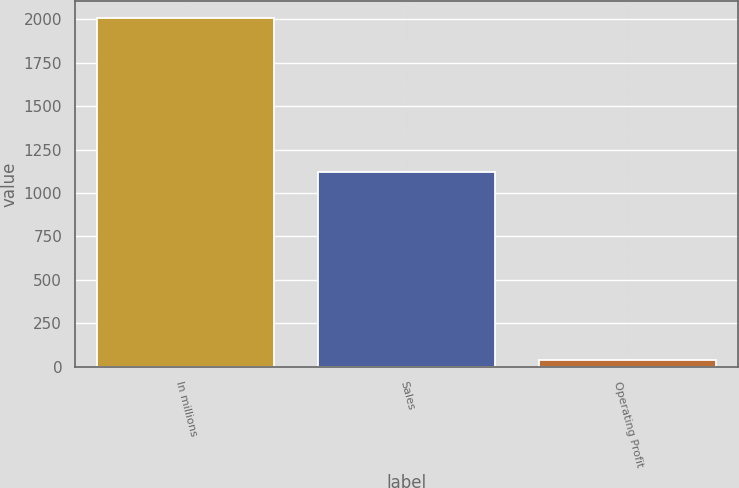Convert chart to OTSL. <chart><loc_0><loc_0><loc_500><loc_500><bar_chart><fcel>In millions<fcel>Sales<fcel>Operating Profit<nl><fcel>2004<fcel>1120<fcel>38<nl></chart> 